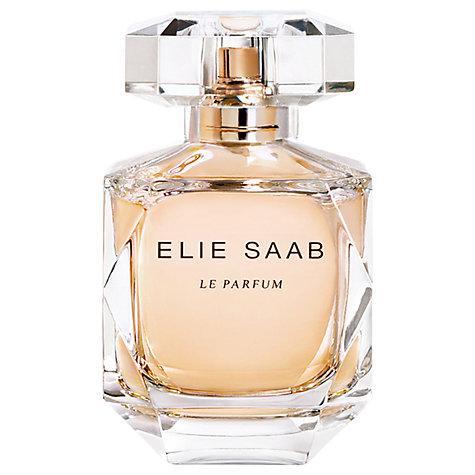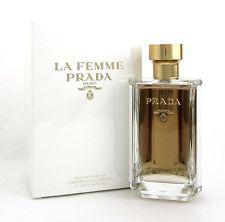The first image is the image on the left, the second image is the image on the right. For the images shown, is this caption "One image shows Prada perfume next to its box and the other shows Prada perfume without a box." true? Answer yes or no. No. 